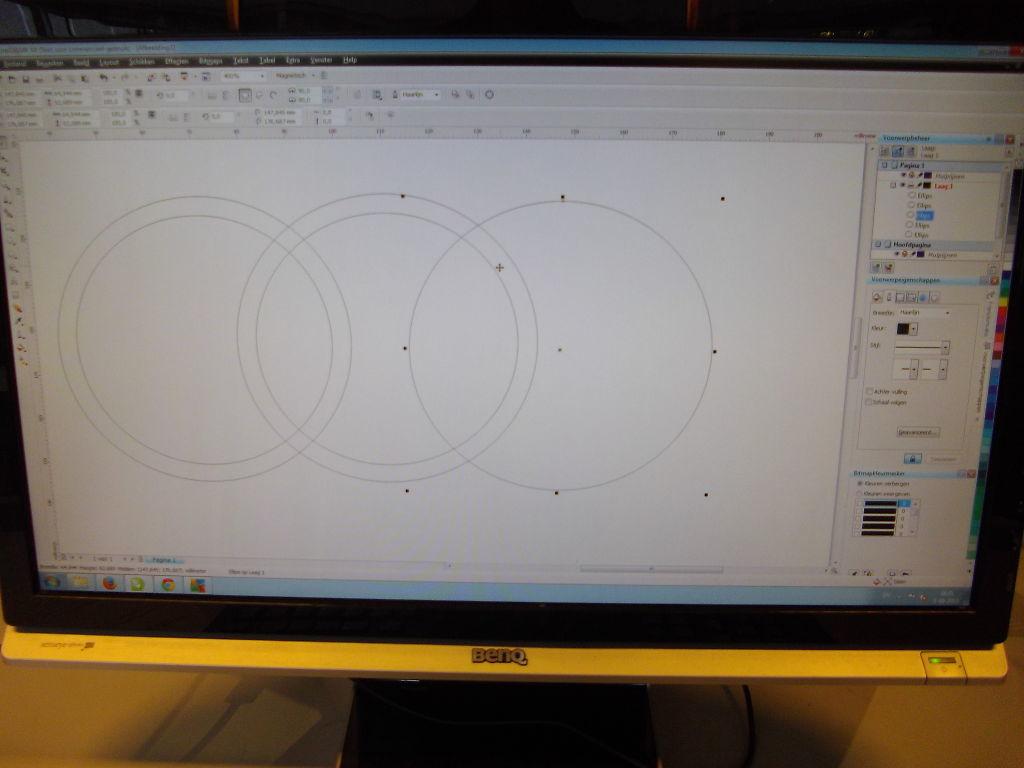What is the brand of this monitor?
Your answer should be very brief. Benq. What is the name of the last menu title on the right?
Your answer should be very brief. Help. 